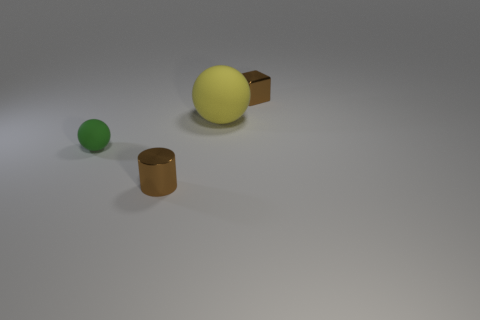Add 1 big balls. How many objects exist? 5 Subtract all cylinders. How many objects are left? 3 Subtract all brown metal objects. Subtract all brown cylinders. How many objects are left? 1 Add 2 small brown objects. How many small brown objects are left? 4 Add 1 big matte balls. How many big matte balls exist? 2 Subtract 0 red spheres. How many objects are left? 4 